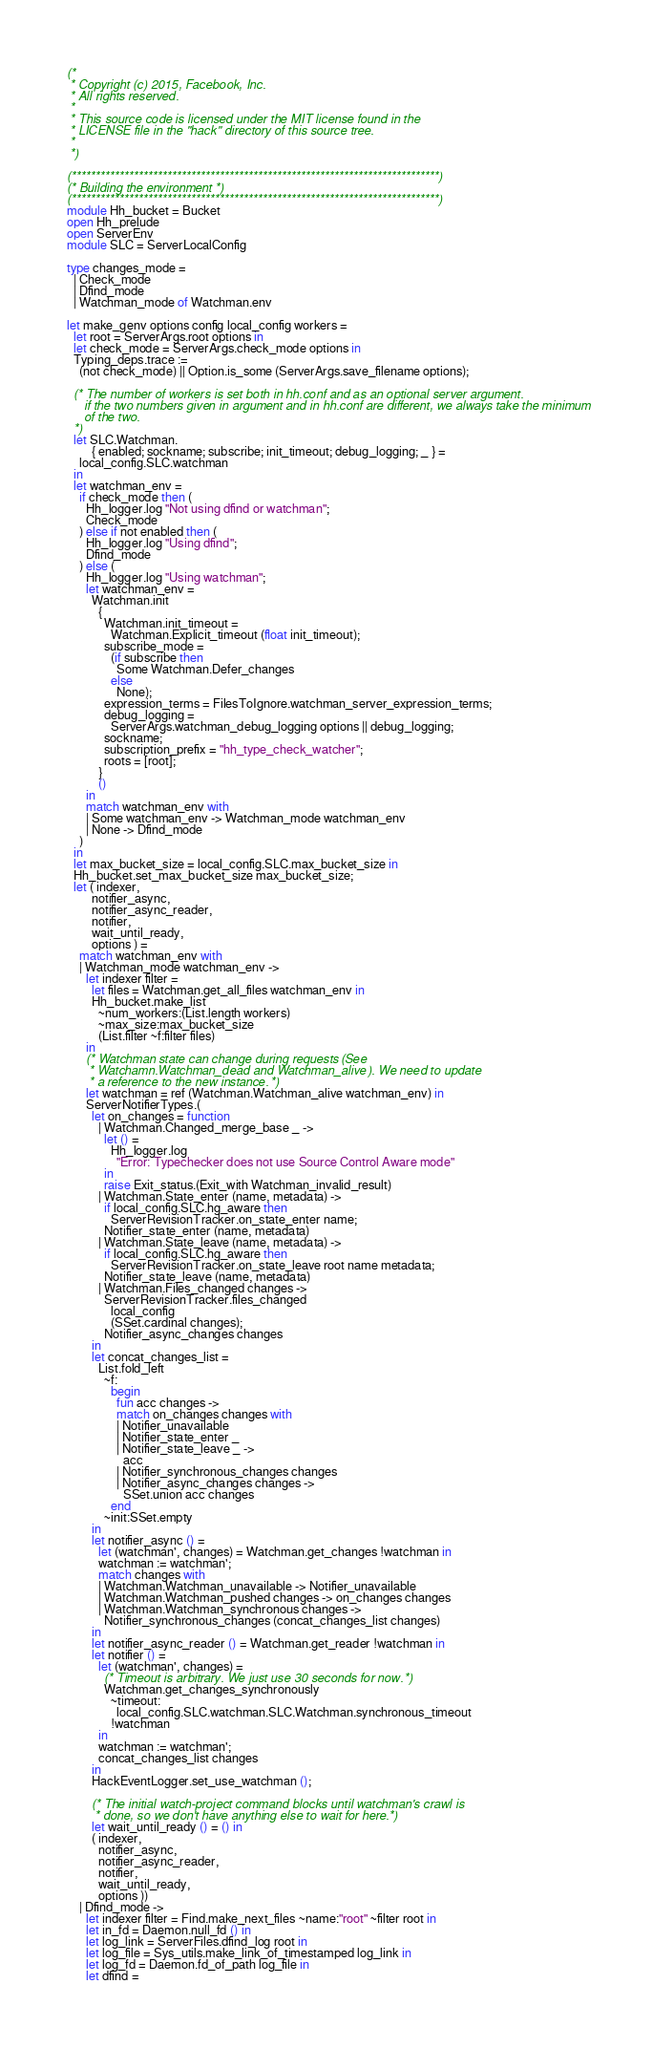<code> <loc_0><loc_0><loc_500><loc_500><_OCaml_>(*
 * Copyright (c) 2015, Facebook, Inc.
 * All rights reserved.
 *
 * This source code is licensed under the MIT license found in the
 * LICENSE file in the "hack" directory of this source tree.
 *
 *)

(*****************************************************************************)
(* Building the environment *)
(*****************************************************************************)
module Hh_bucket = Bucket
open Hh_prelude
open ServerEnv
module SLC = ServerLocalConfig

type changes_mode =
  | Check_mode
  | Dfind_mode
  | Watchman_mode of Watchman.env

let make_genv options config local_config workers =
  let root = ServerArgs.root options in
  let check_mode = ServerArgs.check_mode options in
  Typing_deps.trace :=
    (not check_mode) || Option.is_some (ServerArgs.save_filename options);

  (* The number of workers is set both in hh.conf and as an optional server argument.
     if the two numbers given in argument and in hh.conf are different, we always take the minimum
     of the two.
  *)
  let SLC.Watchman.
        { enabled; sockname; subscribe; init_timeout; debug_logging; _ } =
    local_config.SLC.watchman
  in
  let watchman_env =
    if check_mode then (
      Hh_logger.log "Not using dfind or watchman";
      Check_mode
    ) else if not enabled then (
      Hh_logger.log "Using dfind";
      Dfind_mode
    ) else (
      Hh_logger.log "Using watchman";
      let watchman_env =
        Watchman.init
          {
            Watchman.init_timeout =
              Watchman.Explicit_timeout (float init_timeout);
            subscribe_mode =
              (if subscribe then
                Some Watchman.Defer_changes
              else
                None);
            expression_terms = FilesToIgnore.watchman_server_expression_terms;
            debug_logging =
              ServerArgs.watchman_debug_logging options || debug_logging;
            sockname;
            subscription_prefix = "hh_type_check_watcher";
            roots = [root];
          }
          ()
      in
      match watchman_env with
      | Some watchman_env -> Watchman_mode watchman_env
      | None -> Dfind_mode
    )
  in
  let max_bucket_size = local_config.SLC.max_bucket_size in
  Hh_bucket.set_max_bucket_size max_bucket_size;
  let ( indexer,
        notifier_async,
        notifier_async_reader,
        notifier,
        wait_until_ready,
        options ) =
    match watchman_env with
    | Watchman_mode watchman_env ->
      let indexer filter =
        let files = Watchman.get_all_files watchman_env in
        Hh_bucket.make_list
          ~num_workers:(List.length workers)
          ~max_size:max_bucket_size
          (List.filter ~f:filter files)
      in
      (* Watchman state can change during requests (See
       * Watchamn.Watchman_dead and Watchman_alive). We need to update
       * a reference to the new instance. *)
      let watchman = ref (Watchman.Watchman_alive watchman_env) in
      ServerNotifierTypes.(
        let on_changes = function
          | Watchman.Changed_merge_base _ ->
            let () =
              Hh_logger.log
                "Error: Typechecker does not use Source Control Aware mode"
            in
            raise Exit_status.(Exit_with Watchman_invalid_result)
          | Watchman.State_enter (name, metadata) ->
            if local_config.SLC.hg_aware then
              ServerRevisionTracker.on_state_enter name;
            Notifier_state_enter (name, metadata)
          | Watchman.State_leave (name, metadata) ->
            if local_config.SLC.hg_aware then
              ServerRevisionTracker.on_state_leave root name metadata;
            Notifier_state_leave (name, metadata)
          | Watchman.Files_changed changes ->
            ServerRevisionTracker.files_changed
              local_config
              (SSet.cardinal changes);
            Notifier_async_changes changes
        in
        let concat_changes_list =
          List.fold_left
            ~f:
              begin
                fun acc changes ->
                match on_changes changes with
                | Notifier_unavailable
                | Notifier_state_enter _
                | Notifier_state_leave _ ->
                  acc
                | Notifier_synchronous_changes changes
                | Notifier_async_changes changes ->
                  SSet.union acc changes
              end
            ~init:SSet.empty
        in
        let notifier_async () =
          let (watchman', changes) = Watchman.get_changes !watchman in
          watchman := watchman';
          match changes with
          | Watchman.Watchman_unavailable -> Notifier_unavailable
          | Watchman.Watchman_pushed changes -> on_changes changes
          | Watchman.Watchman_synchronous changes ->
            Notifier_synchronous_changes (concat_changes_list changes)
        in
        let notifier_async_reader () = Watchman.get_reader !watchman in
        let notifier () =
          let (watchman', changes) =
            (* Timeout is arbitrary. We just use 30 seconds for now. *)
            Watchman.get_changes_synchronously
              ~timeout:
                local_config.SLC.watchman.SLC.Watchman.synchronous_timeout
              !watchman
          in
          watchman := watchman';
          concat_changes_list changes
        in
        HackEventLogger.set_use_watchman ();

        (* The initial watch-project command blocks until watchman's crawl is
         * done, so we don't have anything else to wait for here. *)
        let wait_until_ready () = () in
        ( indexer,
          notifier_async,
          notifier_async_reader,
          notifier,
          wait_until_ready,
          options ))
    | Dfind_mode ->
      let indexer filter = Find.make_next_files ~name:"root" ~filter root in
      let in_fd = Daemon.null_fd () in
      let log_link = ServerFiles.dfind_log root in
      let log_file = Sys_utils.make_link_of_timestamped log_link in
      let log_fd = Daemon.fd_of_path log_file in
      let dfind =</code> 